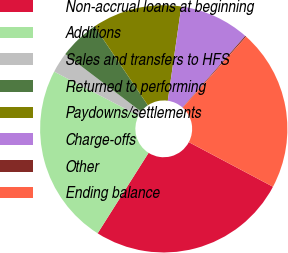Convert chart to OTSL. <chart><loc_0><loc_0><loc_500><loc_500><pie_chart><fcel>Non-accrual loans at beginning<fcel>Additions<fcel>Sales and transfers to HFS<fcel>Returned to performing<fcel>Paydowns/settlements<fcel>Charge-offs<fcel>Other<fcel>Ending balance<nl><fcel>26.22%<fcel>23.68%<fcel>2.68%<fcel>5.21%<fcel>11.72%<fcel>9.19%<fcel>0.15%<fcel>21.15%<nl></chart> 